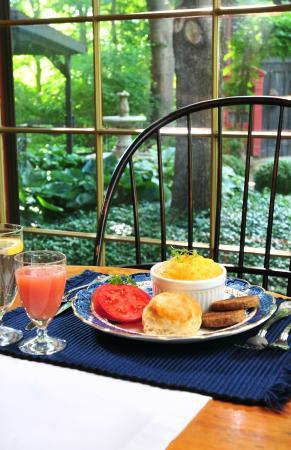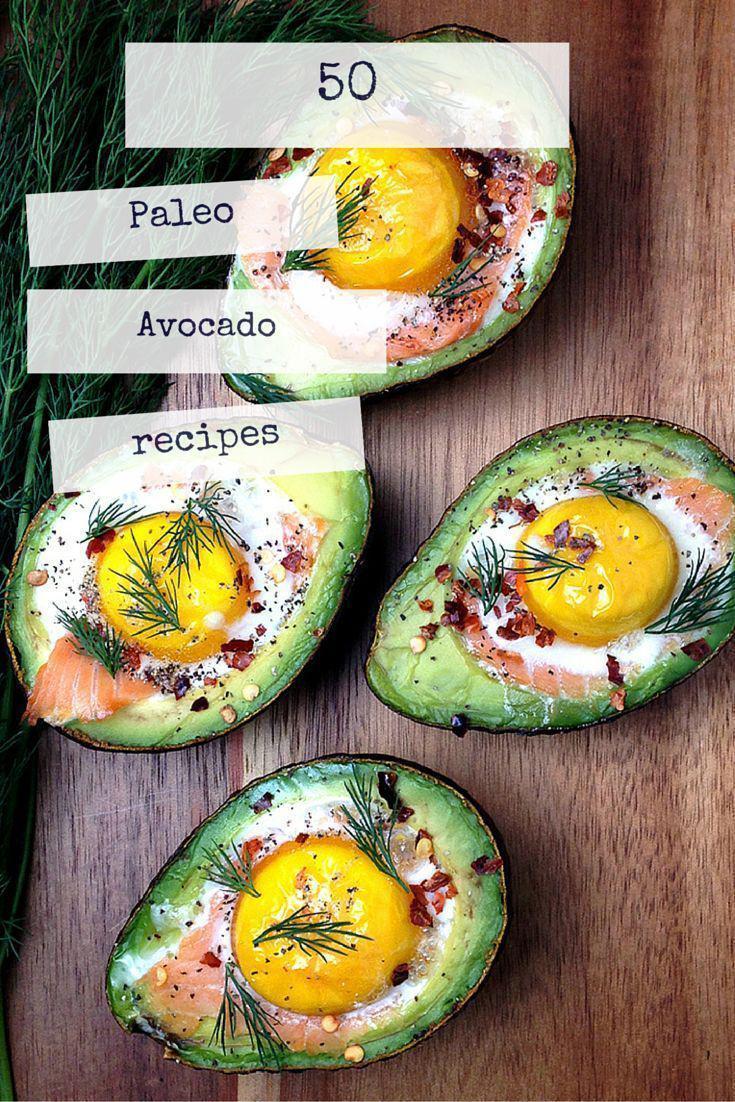The first image is the image on the left, the second image is the image on the right. For the images displayed, is the sentence "Each image shows acorn caps made of wrapped twine, and at least one image includes acorns made of plastic eggs in orange, yellow and green colors." factually correct? Answer yes or no. No. The first image is the image on the left, the second image is the image on the right. For the images shown, is this caption "Nothing is edible." true? Answer yes or no. No. 